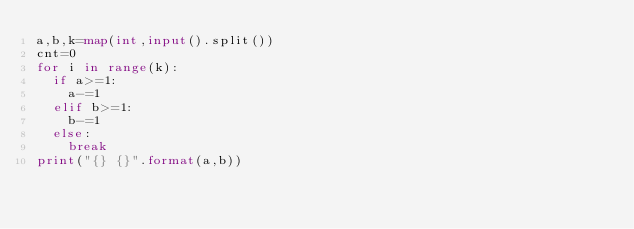Convert code to text. <code><loc_0><loc_0><loc_500><loc_500><_Python_>a,b,k=map(int,input().split())
cnt=0
for i in range(k):
  if a>=1:
    a-=1
  elif b>=1:
    b-=1
  else:
    break
print("{} {}".format(a,b))</code> 